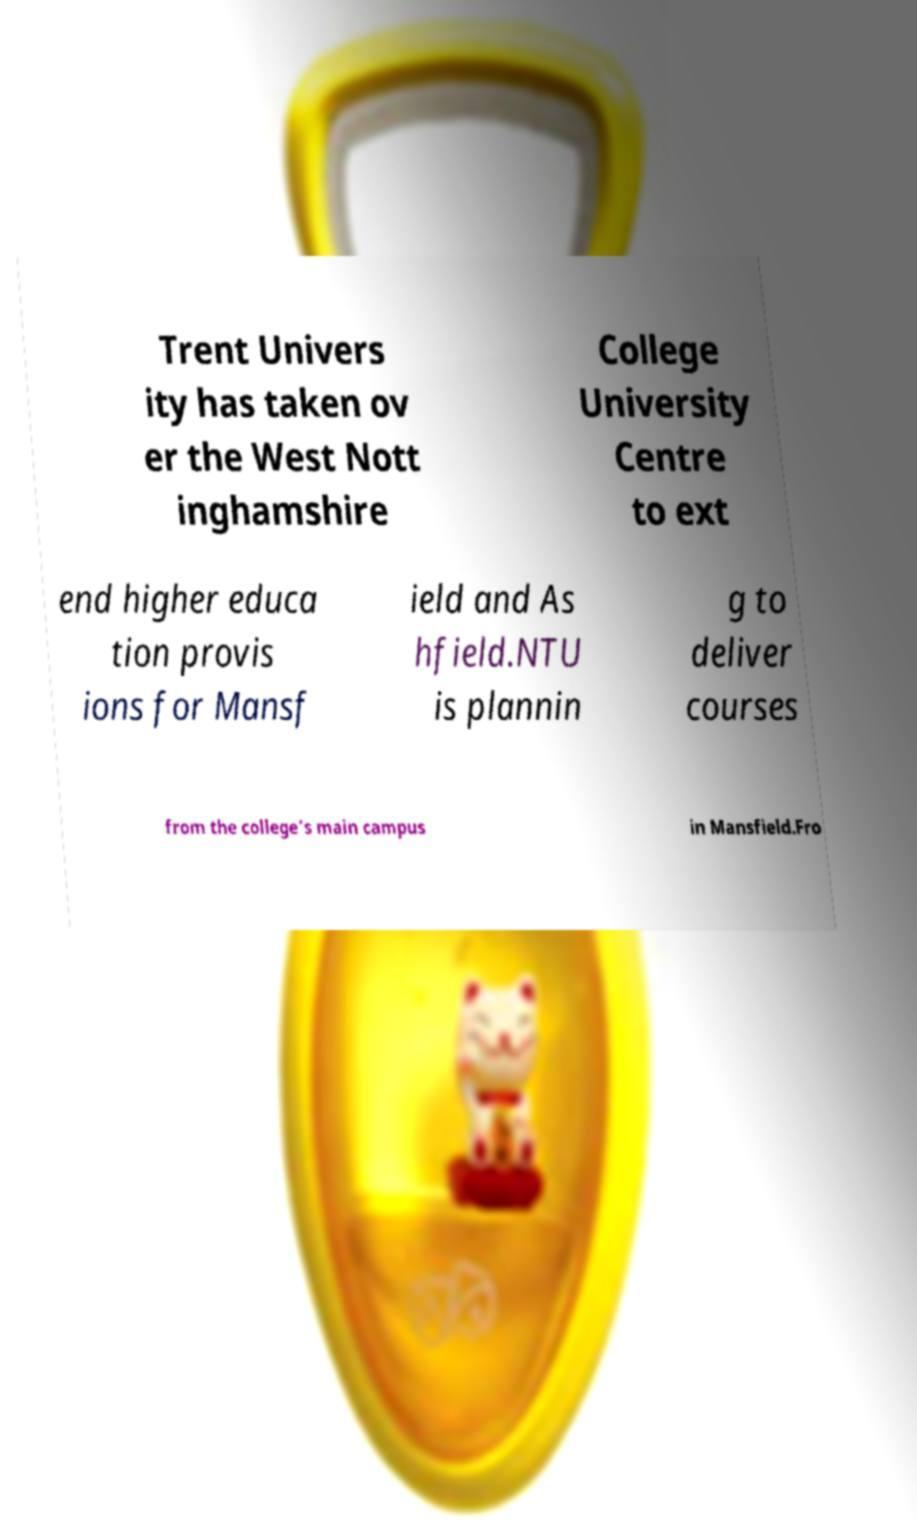There's text embedded in this image that I need extracted. Can you transcribe it verbatim? Trent Univers ity has taken ov er the West Nott inghamshire College University Centre to ext end higher educa tion provis ions for Mansf ield and As hfield.NTU is plannin g to deliver courses from the college’s main campus in Mansfield.Fro 